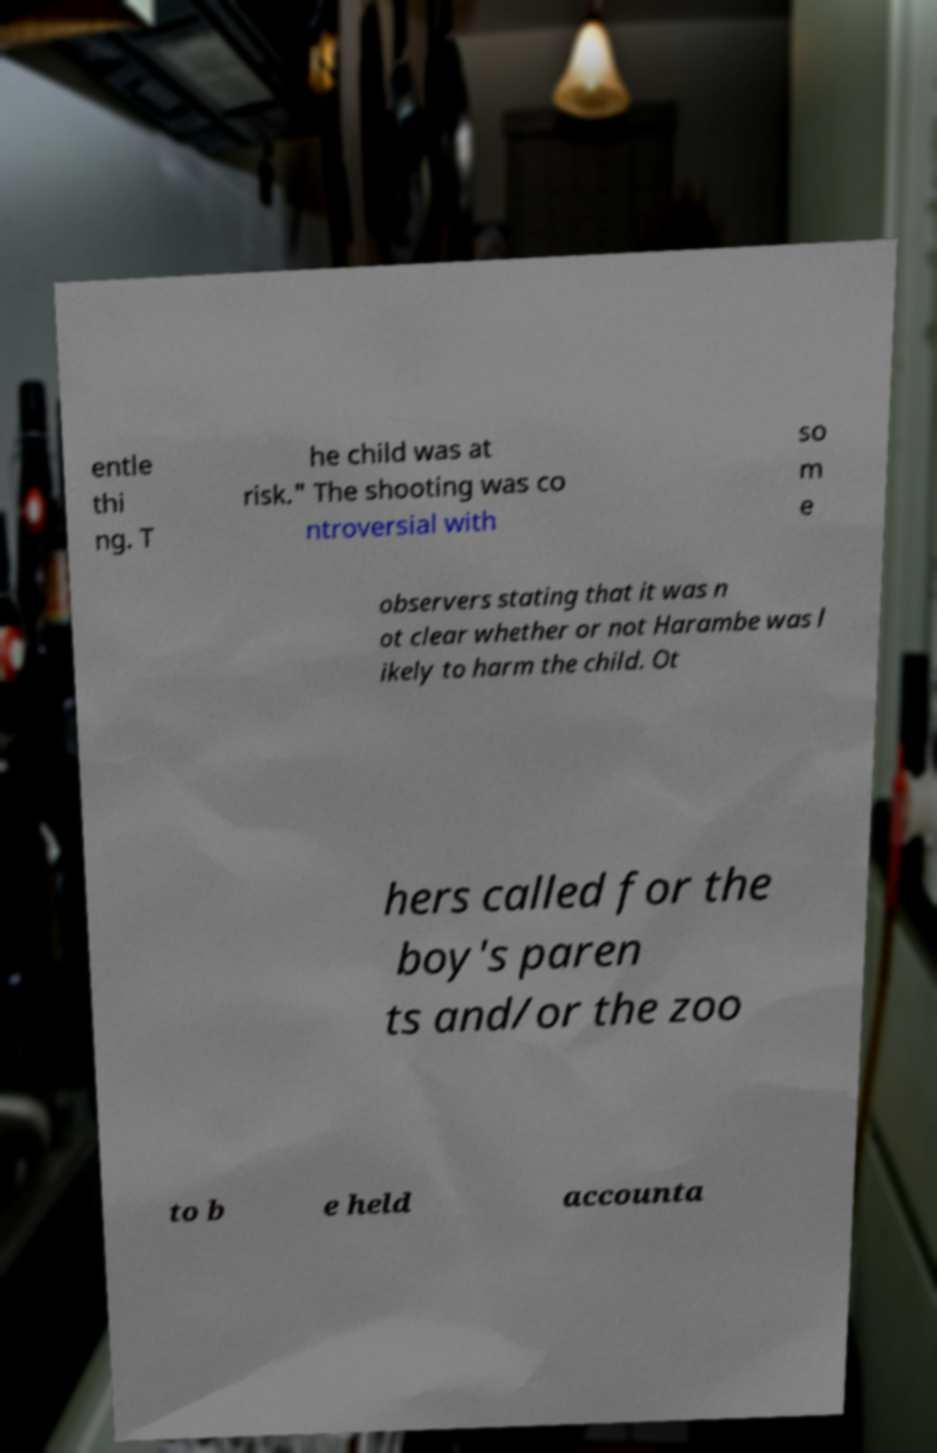Could you extract and type out the text from this image? entle thi ng. T he child was at risk." The shooting was co ntroversial with so m e observers stating that it was n ot clear whether or not Harambe was l ikely to harm the child. Ot hers called for the boy's paren ts and/or the zoo to b e held accounta 